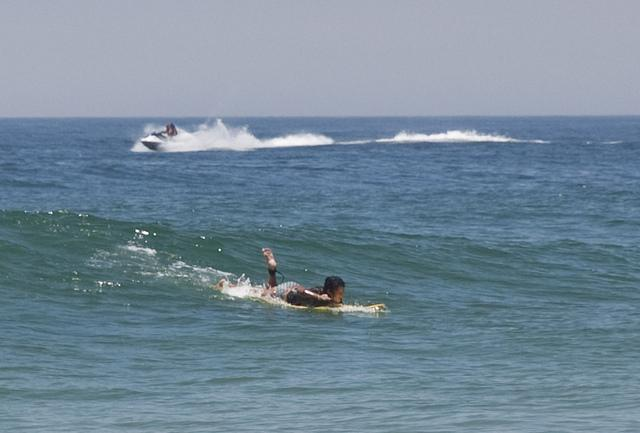Which person seen here goes faster over time?

Choices:
A) shark rider
B) boat
C) surfer
D) canoe boat 